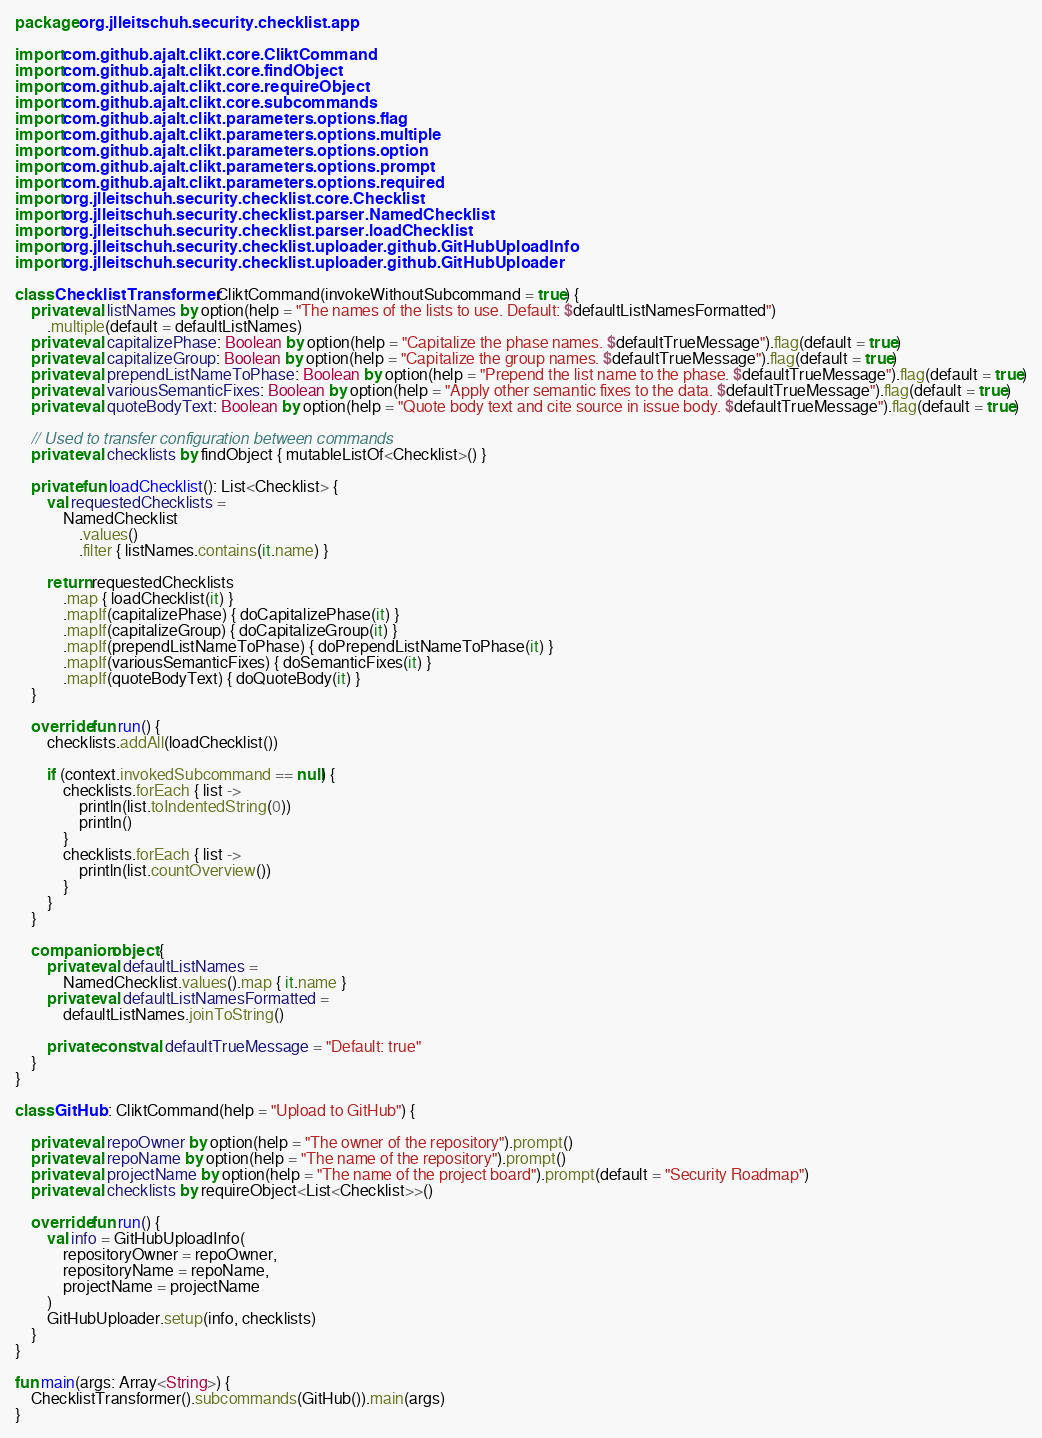Convert code to text. <code><loc_0><loc_0><loc_500><loc_500><_Kotlin_>package org.jlleitschuh.security.checklist.app

import com.github.ajalt.clikt.core.CliktCommand
import com.github.ajalt.clikt.core.findObject
import com.github.ajalt.clikt.core.requireObject
import com.github.ajalt.clikt.core.subcommands
import com.github.ajalt.clikt.parameters.options.flag
import com.github.ajalt.clikt.parameters.options.multiple
import com.github.ajalt.clikt.parameters.options.option
import com.github.ajalt.clikt.parameters.options.prompt
import com.github.ajalt.clikt.parameters.options.required
import org.jlleitschuh.security.checklist.core.Checklist
import org.jlleitschuh.security.checklist.parser.NamedChecklist
import org.jlleitschuh.security.checklist.parser.loadChecklist
import org.jlleitschuh.security.checklist.uploader.github.GitHubUploadInfo
import org.jlleitschuh.security.checklist.uploader.github.GitHubUploader

class ChecklistTransformer : CliktCommand(invokeWithoutSubcommand = true) {
    private val listNames by option(help = "The names of the lists to use. Default: $defaultListNamesFormatted")
        .multiple(default = defaultListNames)
    private val capitalizePhase: Boolean by option(help = "Capitalize the phase names. $defaultTrueMessage").flag(default = true)
    private val capitalizeGroup: Boolean by option(help = "Capitalize the group names. $defaultTrueMessage").flag(default = true)
    private val prependListNameToPhase: Boolean by option(help = "Prepend the list name to the phase. $defaultTrueMessage").flag(default = true)
    private val variousSemanticFixes: Boolean by option(help = "Apply other semantic fixes to the data. $defaultTrueMessage").flag(default = true)
    private val quoteBodyText: Boolean by option(help = "Quote body text and cite source in issue body. $defaultTrueMessage").flag(default = true)

    // Used to transfer configuration between commands
    private val checklists by findObject { mutableListOf<Checklist>() }

    private fun loadChecklist(): List<Checklist> {
        val requestedChecklists =
            NamedChecklist
                .values()
                .filter { listNames.contains(it.name) }

        return requestedChecklists
            .map { loadChecklist(it) }
            .mapIf(capitalizePhase) { doCapitalizePhase(it) }
            .mapIf(capitalizeGroup) { doCapitalizeGroup(it) }
            .mapIf(prependListNameToPhase) { doPrependListNameToPhase(it) }
            .mapIf(variousSemanticFixes) { doSemanticFixes(it) }
            .mapIf(quoteBodyText) { doQuoteBody(it) }
    }

    override fun run() {
        checklists.addAll(loadChecklist())

        if (context.invokedSubcommand == null) {
            checklists.forEach { list ->
                println(list.toIndentedString(0))
                println()
            }
            checklists.forEach { list ->
                println(list.countOverview())
            }
        }
    }

    companion object {
        private val defaultListNames =
            NamedChecklist.values().map { it.name }
        private val defaultListNamesFormatted =
            defaultListNames.joinToString()

        private const val defaultTrueMessage = "Default: true"
    }
}

class GitHub : CliktCommand(help = "Upload to GitHub") {

    private val repoOwner by option(help = "The owner of the repository").prompt()
    private val repoName by option(help = "The name of the repository").prompt()
    private val projectName by option(help = "The name of the project board").prompt(default = "Security Roadmap")
    private val checklists by requireObject<List<Checklist>>()

    override fun run() {
        val info = GitHubUploadInfo(
            repositoryOwner = repoOwner,
            repositoryName = repoName,
            projectName = projectName
        )
        GitHubUploader.setup(info, checklists)
    }
}

fun main(args: Array<String>) {
    ChecklistTransformer().subcommands(GitHub()).main(args)
}
</code> 